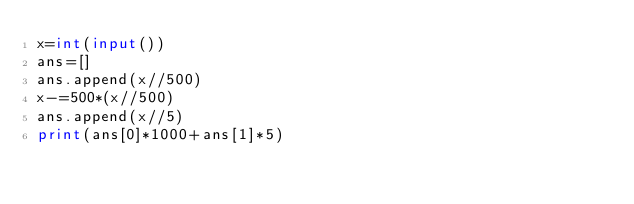<code> <loc_0><loc_0><loc_500><loc_500><_Python_>x=int(input())
ans=[]
ans.append(x//500)
x-=500*(x//500)
ans.append(x//5)
print(ans[0]*1000+ans[1]*5)</code> 